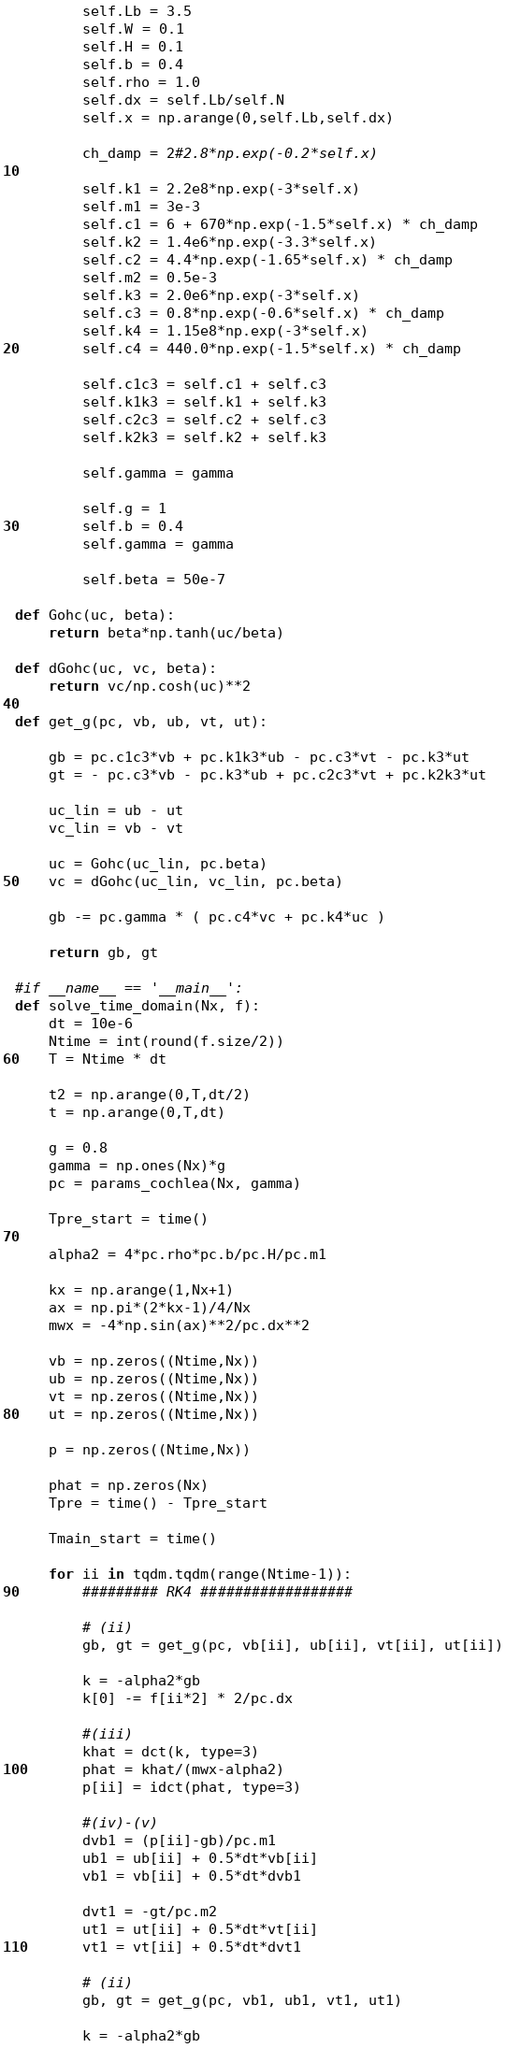Convert code to text. <code><loc_0><loc_0><loc_500><loc_500><_Python_>        self.Lb = 3.5
        self.W = 0.1
        self.H = 0.1
        self.b = 0.4
        self.rho = 1.0
        self.dx = self.Lb/self.N
        self.x = np.arange(0,self.Lb,self.dx)

        ch_damp = 2#2.8*np.exp(-0.2*self.x)
        
        self.k1 = 2.2e8*np.exp(-3*self.x)
        self.m1 = 3e-3
        self.c1 = 6 + 670*np.exp(-1.5*self.x) * ch_damp
        self.k2 = 1.4e6*np.exp(-3.3*self.x)
        self.c2 = 4.4*np.exp(-1.65*self.x) * ch_damp
        self.m2 = 0.5e-3
        self.k3 = 2.0e6*np.exp(-3*self.x)
        self.c3 = 0.8*np.exp(-0.6*self.x) * ch_damp
        self.k4 = 1.15e8*np.exp(-3*self.x)
        self.c4 = 440.0*np.exp(-1.5*self.x) * ch_damp

        self.c1c3 = self.c1 + self.c3
        self.k1k3 = self.k1 + self.k3
        self.c2c3 = self.c2 + self.c3
        self.k2k3 = self.k2 + self.k3

        self.gamma = gamma

        self.g = 1
        self.b = 0.4
        self.gamma = gamma

        self.beta = 50e-7

def Gohc(uc, beta):
    return beta*np.tanh(uc/beta)

def dGohc(uc, vc, beta):
    return vc/np.cosh(uc)**2

def get_g(pc, vb, ub, vt, ut):

    gb = pc.c1c3*vb + pc.k1k3*ub - pc.c3*vt - pc.k3*ut
    gt = - pc.c3*vb - pc.k3*ub + pc.c2c3*vt + pc.k2k3*ut

    uc_lin = ub - ut
    vc_lin = vb - vt

    uc = Gohc(uc_lin, pc.beta)
    vc = dGohc(uc_lin, vc_lin, pc.beta)

    gb -= pc.gamma * ( pc.c4*vc + pc.k4*uc )

    return gb, gt

#if __name__ == '__main__':
def solve_time_domain(Nx, f):
    dt = 10e-6
    Ntime = int(round(f.size/2))
    T = Ntime * dt

    t2 = np.arange(0,T,dt/2)
    t = np.arange(0,T,dt)

    g = 0.8
    gamma = np.ones(Nx)*g
    pc = params_cochlea(Nx, gamma)

    Tpre_start = time()

    alpha2 = 4*pc.rho*pc.b/pc.H/pc.m1

    kx = np.arange(1,Nx+1)
    ax = np.pi*(2*kx-1)/4/Nx
    mwx = -4*np.sin(ax)**2/pc.dx**2

    vb = np.zeros((Ntime,Nx))
    ub = np.zeros((Ntime,Nx))
    vt = np.zeros((Ntime,Nx))
    ut = np.zeros((Ntime,Nx))

    p = np.zeros((Ntime,Nx))

    phat = np.zeros(Nx)
    Tpre = time() - Tpre_start

    Tmain_start = time()

    for ii in tqdm.tqdm(range(Ntime-1)):
        ######### RK4 ##################

        # (ii)
        gb, gt = get_g(pc, vb[ii], ub[ii], vt[ii], ut[ii])

        k = -alpha2*gb
        k[0] -= f[ii*2] * 2/pc.dx
        
        #(iii)
        khat = dct(k, type=3)
        phat = khat/(mwx-alpha2)
        p[ii] = idct(phat, type=3)

        #(iv)-(v)
        dvb1 = (p[ii]-gb)/pc.m1 
        ub1 = ub[ii] + 0.5*dt*vb[ii]
        vb1 = vb[ii] + 0.5*dt*dvb1

        dvt1 = -gt/pc.m2
        ut1 = ut[ii] + 0.5*dt*vt[ii]
        vt1 = vt[ii] + 0.5*dt*dvt1    
        
        # (ii)
        gb, gt = get_g(pc, vb1, ub1, vt1, ut1) 

        k = -alpha2*gb</code> 